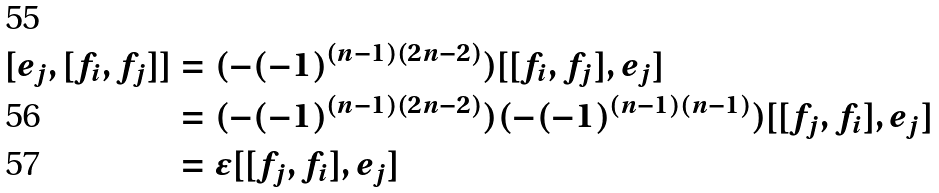<formula> <loc_0><loc_0><loc_500><loc_500>[ e _ { j } , [ f _ { i } , f _ { j } ] ] & = ( - ( - 1 ) ^ { ( n - 1 ) ( 2 n - 2 ) } ) [ [ f _ { i } , f _ { j } ] , e _ { j } ] \\ & = ( - ( - 1 ) ^ { ( n - 1 ) ( 2 n - 2 ) } ) ( - ( - 1 ) ^ { ( n - 1 ) ( n - 1 ) } ) [ [ f _ { j } , f _ { i } ] , e _ { j } ] \\ & = \epsilon [ [ f _ { j } , f _ { i } ] , e _ { j } ]</formula> 